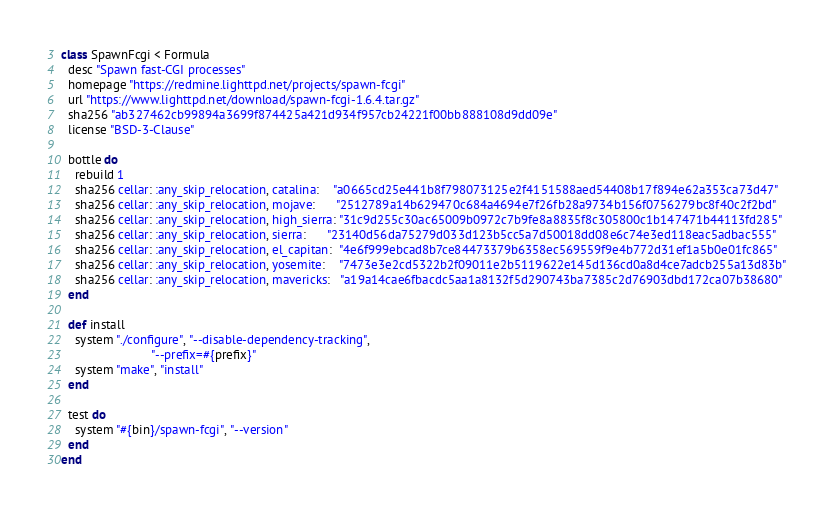<code> <loc_0><loc_0><loc_500><loc_500><_Ruby_>class SpawnFcgi < Formula
  desc "Spawn fast-CGI processes"
  homepage "https://redmine.lighttpd.net/projects/spawn-fcgi"
  url "https://www.lighttpd.net/download/spawn-fcgi-1.6.4.tar.gz"
  sha256 "ab327462cb99894a3699f874425a421d934f957cb24221f00bb888108d9dd09e"
  license "BSD-3-Clause"

  bottle do
    rebuild 1
    sha256 cellar: :any_skip_relocation, catalina:    "a0665cd25e441b8f798073125e2f4151588aed54408b17f894e62a353ca73d47"
    sha256 cellar: :any_skip_relocation, mojave:      "2512789a14b629470c684a4694e7f26fb28a9734b156f0756279bc8f40c2f2bd"
    sha256 cellar: :any_skip_relocation, high_sierra: "31c9d255c30ac65009b0972c7b9fe8a8835f8c305800c1b147471b44113fd285"
    sha256 cellar: :any_skip_relocation, sierra:      "23140d56da75279d033d123b5cc5a7d50018dd08e6c74e3ed118eac5adbac555"
    sha256 cellar: :any_skip_relocation, el_capitan:  "4e6f999ebcad8b7ce84473379b6358ec569559f9e4b772d31ef1a5b0e01fc865"
    sha256 cellar: :any_skip_relocation, yosemite:    "7473e3e2cd5322b2f09011e2b5119622e145d136cd0a8d4ce7adcb255a13d83b"
    sha256 cellar: :any_skip_relocation, mavericks:   "a19a14cae6fbacdc5aa1a8132f5d290743ba7385c2d76903dbd172ca07b38680"
  end

  def install
    system "./configure", "--disable-dependency-tracking",
                          "--prefix=#{prefix}"
    system "make", "install"
  end

  test do
    system "#{bin}/spawn-fcgi", "--version"
  end
end
</code> 